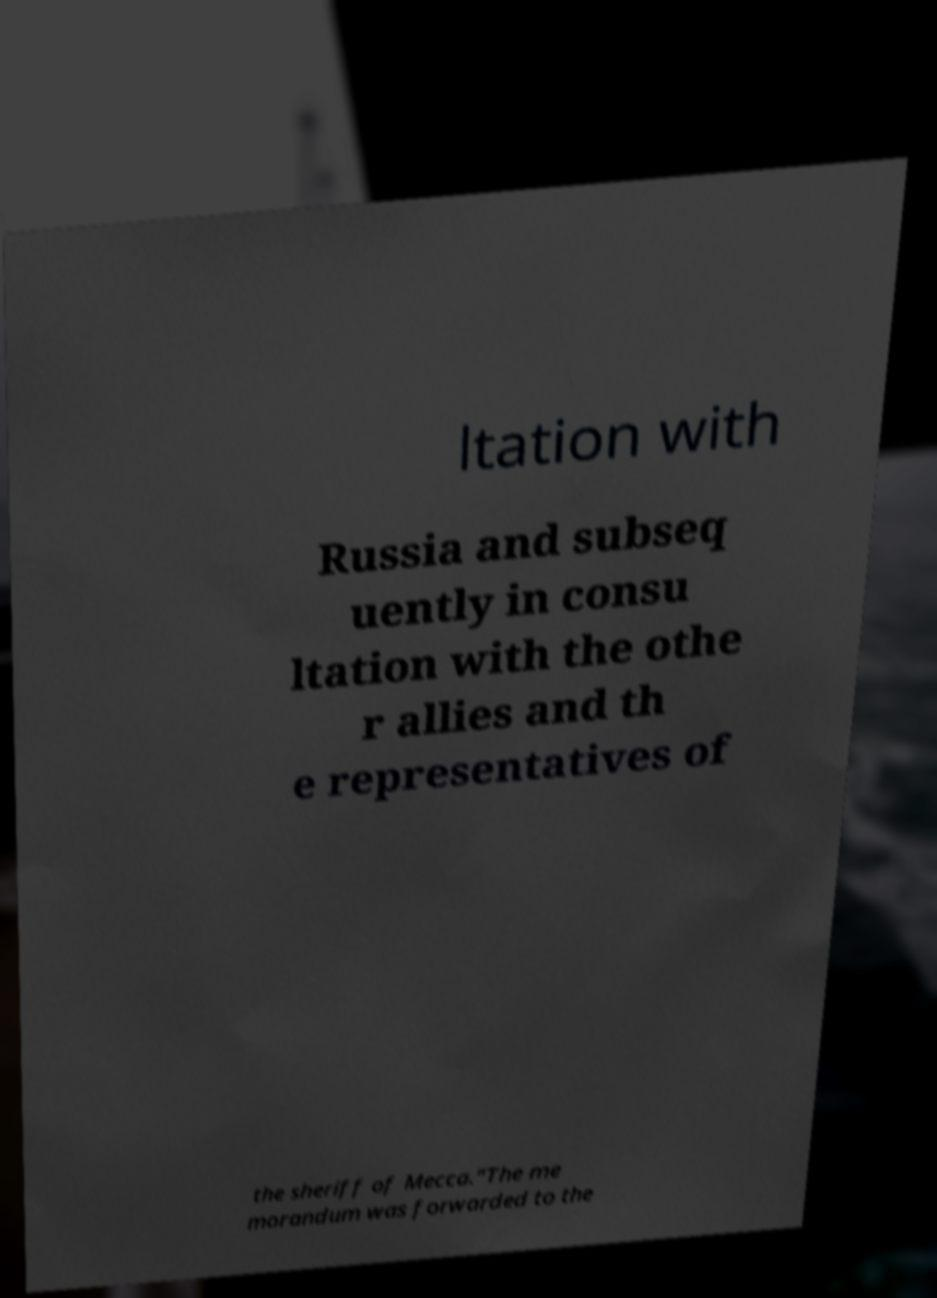Can you read and provide the text displayed in the image?This photo seems to have some interesting text. Can you extract and type it out for me? ltation with Russia and subseq uently in consu ltation with the othe r allies and th e representatives of the sheriff of Mecca."The me morandum was forwarded to the 